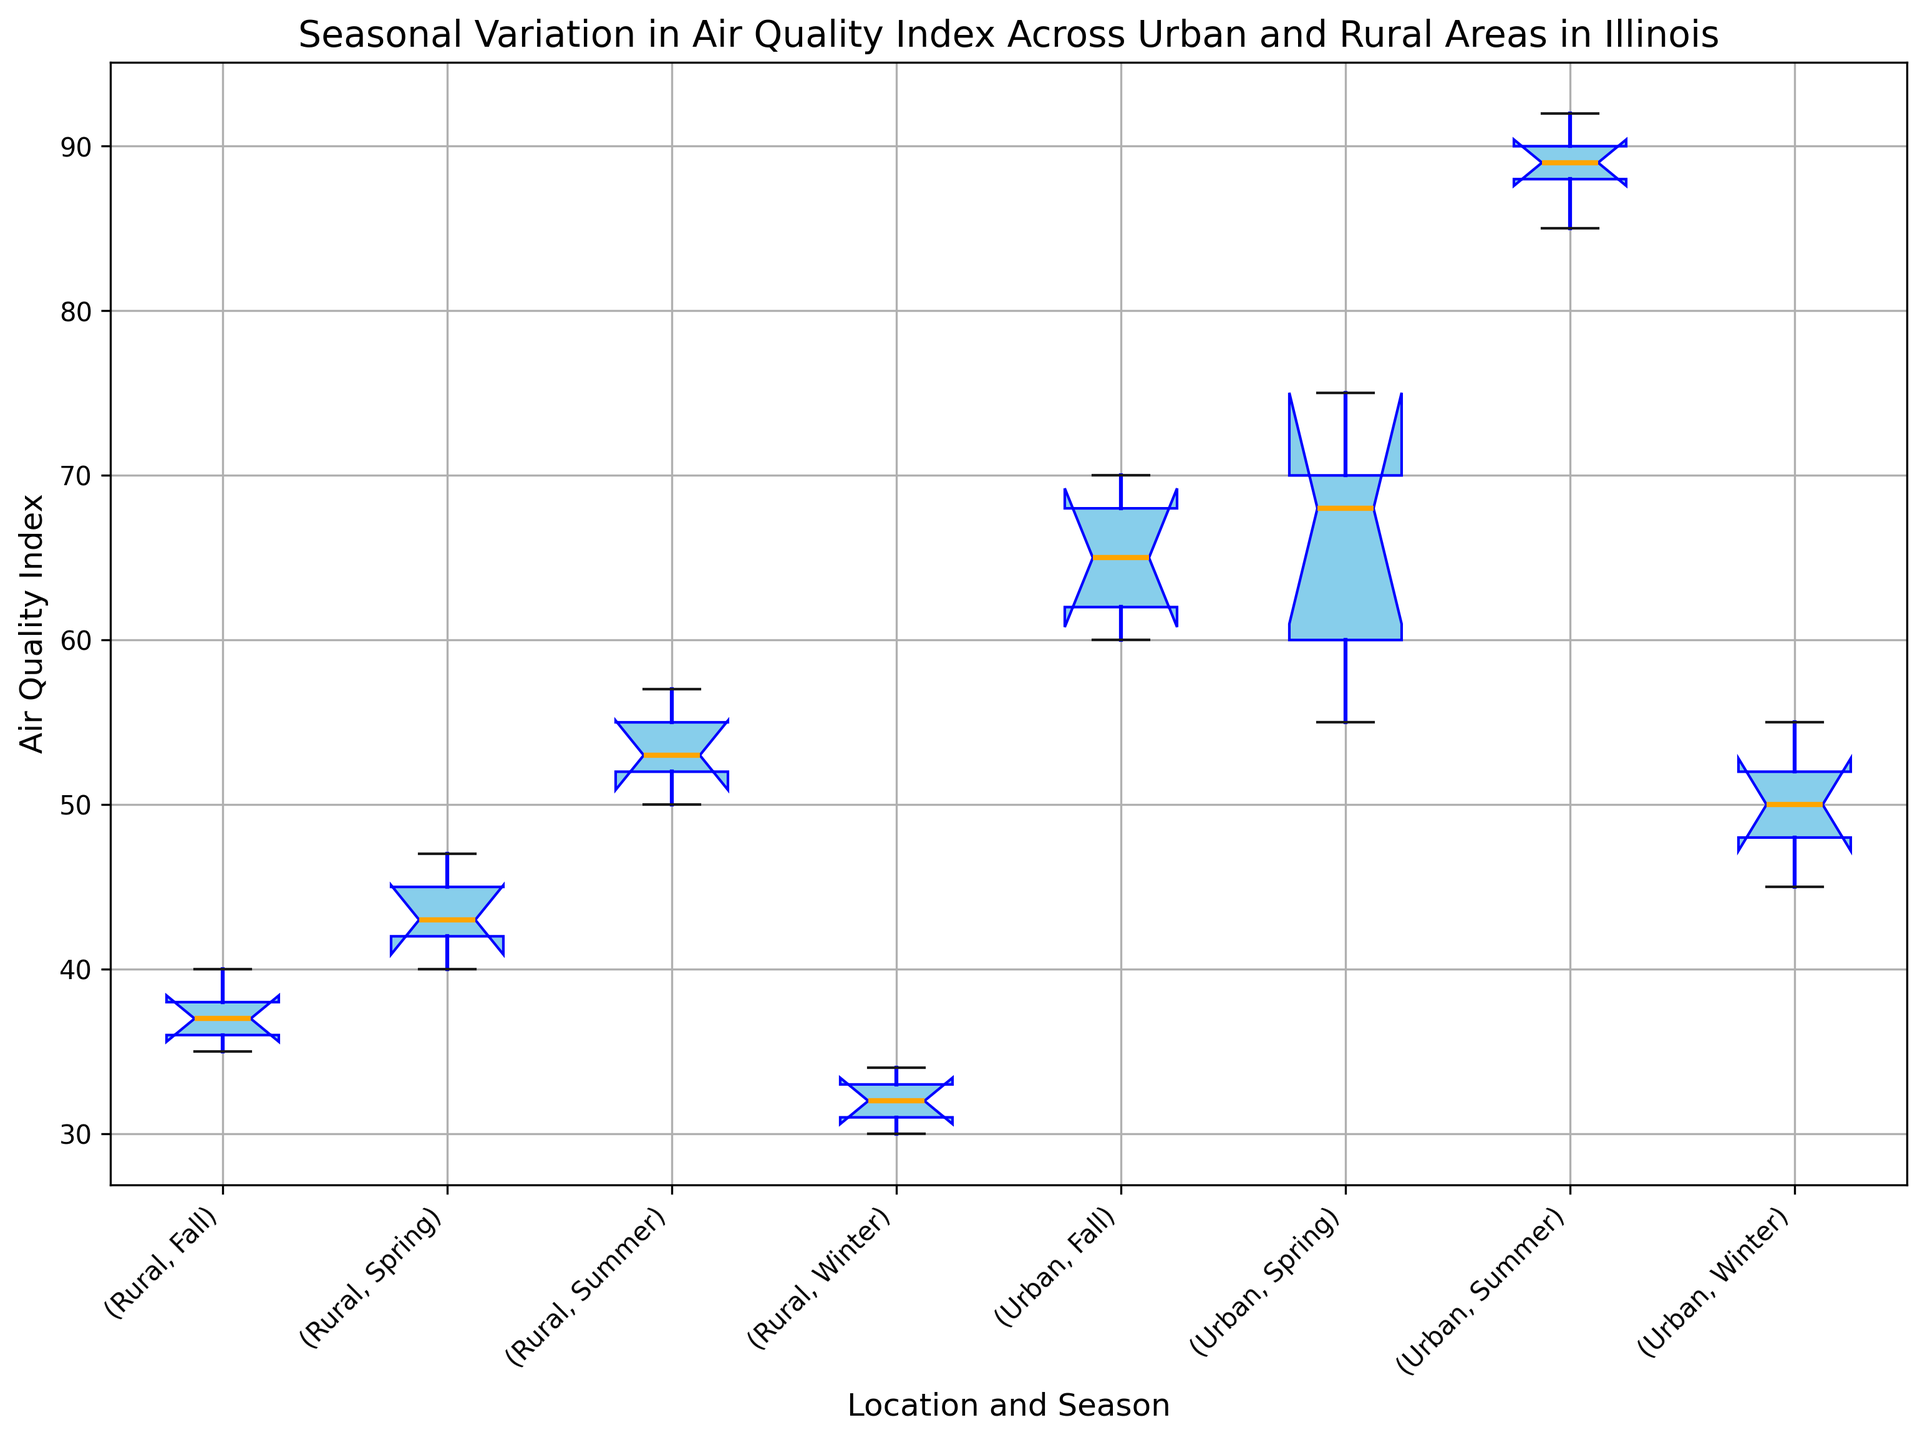What season has the highest median Air Quality Index in Urban areas? The median is indicated by the orange line within the boxes for each category. For Urban areas, the summer box has the highest position of this line.
Answer: Summer How does the median Air Quality Index for Urban areas in Winter compare to Rural areas in Winter? The median is the orange line within the boxes. The line for Urban Winter is higher than for Rural Winter.
Answer: Higher What is the interquartile range (IQR) for Air Quality Index in Rural areas during Summer? The IQR is the range between the lower and upper quartiles (bottom and top edges of the box). For Rural Summer, it spans from around 52 to 55. So, the IQR is 55 - 52.
Answer: 3 Which location and season combination shows the widest range in Air Quality Index data? The range is determined by the length of the whiskers (which show the spread of the data). Urban Summer has the widest range from approximately 85 to 92.
Answer: Urban Summer How does the variability of Air Quality Index in Urban Fall compare to Rural Fall? The variability is indicated by the length of the box and whiskers. Urban Fall has a larger box and longer whiskers compared to Rural Fall, indicating higher variability.
Answer: Higher In which season does the Air Quality Index for Urban areas display the least variability? Variability is shown by the length of the box and whiskers. For Urban areas, Winter has the shortest box and whiskers.
Answer: Winter What is the median Air Quality Index for Urban areas across all seasons? Check the median (orange line) in each season for Urban areas: Spring (around 68), Summer (around 89), Fall (around 65), and Winter (around 50).
Answer: Spring: ~68, Summer: ~89, Fall: ~65, Winter: ~50 Compare the upper quartile of the Air Quality Index for Rural Spring and Rural Summer. The upper quartile is the top edge of the box. Rural Spring's upper quartile is around 47, whereas Rural Summer's is around 55.
Answer: Lower in Spring What are the lower and upper bounds of the Air Quality Index for Urban Winter? The lower and upper bounds are shown by the ends of the whiskers. For Urban Winter, the bounds are around 45 (lower) and 55 (upper).
Answer: 45, 55 